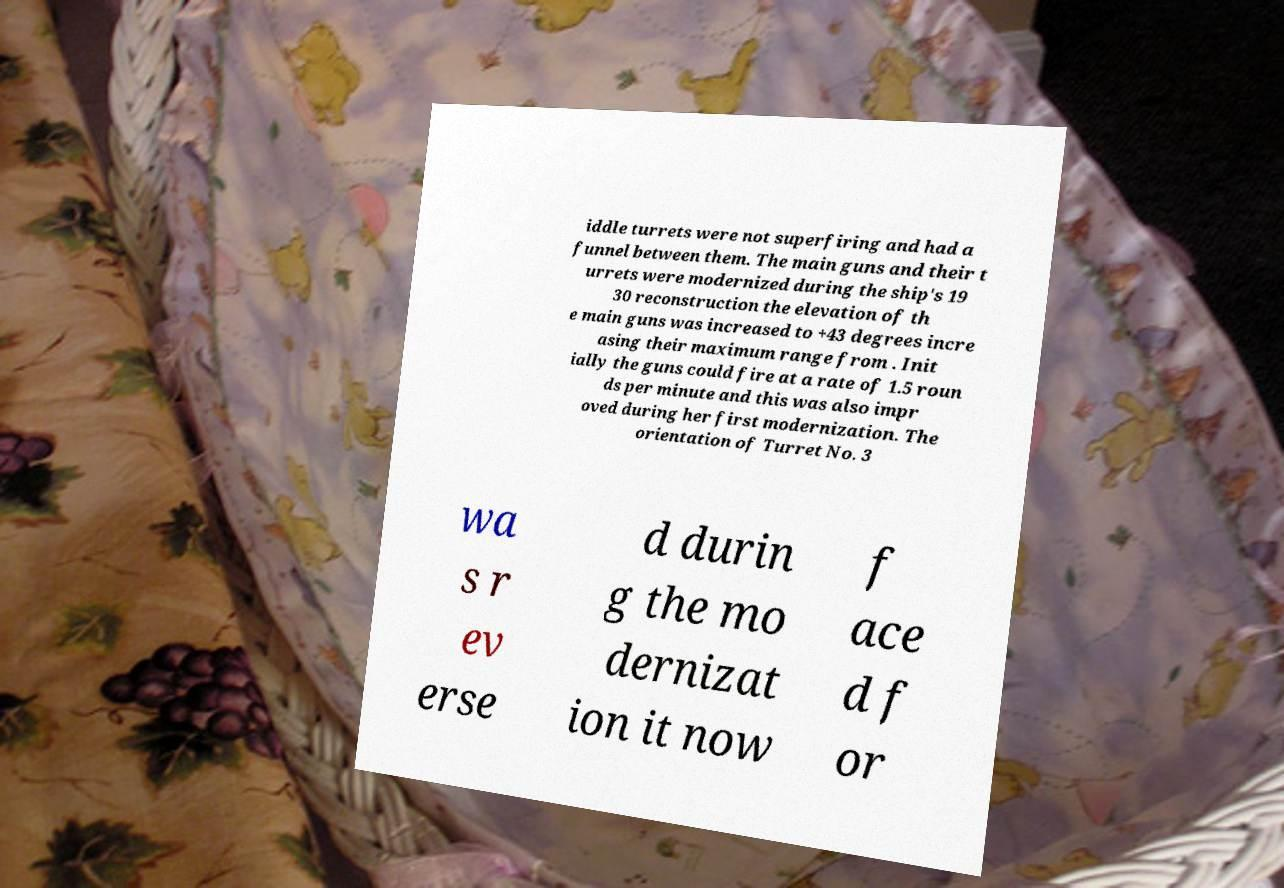Can you read and provide the text displayed in the image?This photo seems to have some interesting text. Can you extract and type it out for me? iddle turrets were not superfiring and had a funnel between them. The main guns and their t urrets were modernized during the ship's 19 30 reconstruction the elevation of th e main guns was increased to +43 degrees incre asing their maximum range from . Init ially the guns could fire at a rate of 1.5 roun ds per minute and this was also impr oved during her first modernization. The orientation of Turret No. 3 wa s r ev erse d durin g the mo dernizat ion it now f ace d f or 